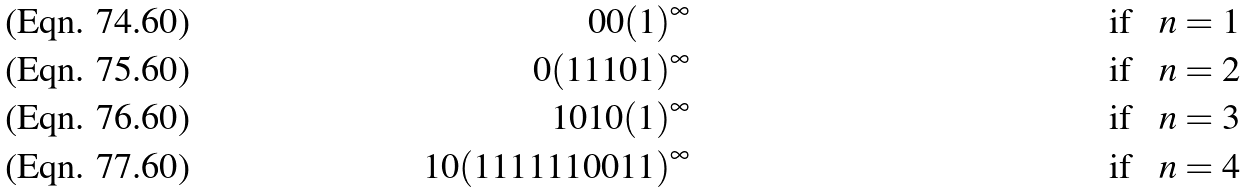<formula> <loc_0><loc_0><loc_500><loc_500>0 0 ( 1 ) ^ { \infty } & & \text {if \ \ $n=1$} \\ 0 ( 1 1 1 0 1 ) ^ { \infty } & & \text {if \ \ $n=2$} \\ 1 0 1 0 ( 1 ) ^ { \infty } & & \text {if \ \ $n=3$} \\ 1 0 ( 1 1 1 1 1 1 0 0 1 1 ) ^ { \infty } & & \text {if \ \ $n=4$}</formula> 